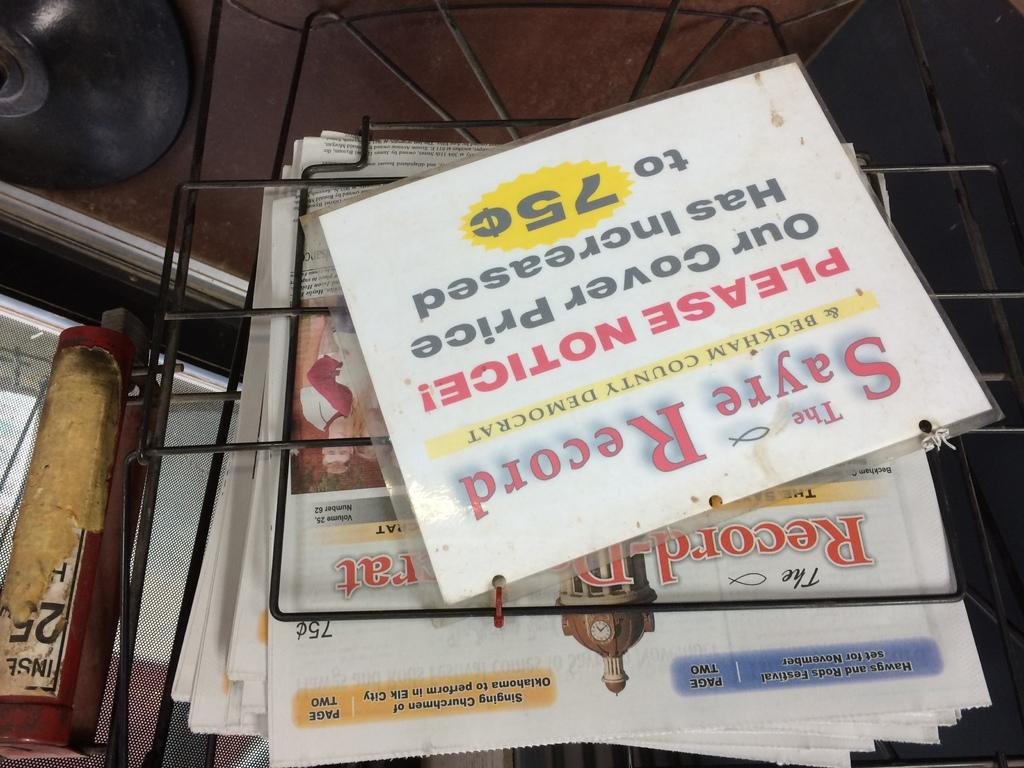What is the main object in the image? There is a board in the image. What other items can be seen on or around the board? There are newspapers, a book, and a CD present in the image. What is the CD's location in the image? The CD is in the top left of the image. What is the metal object associated with the newspapers? The metal object associated with the newspapers is likely a paper clip or a staple, used to keep the newspapers together. What type of soda is being poured from the metal thing in the image? There is no soda present in the image, and the metal object associated with the newspapers is not a soda container. 